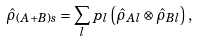Convert formula to latex. <formula><loc_0><loc_0><loc_500><loc_500>\hat { \rho } _ { ( A + B ) s } = \sum _ { l } p _ { l } \left ( \hat { \rho } _ { A l } \otimes \hat { \rho } _ { B l } \right ) ,</formula> 